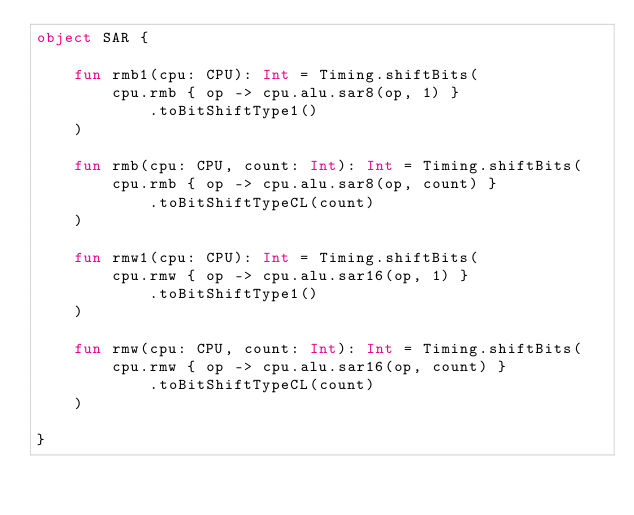Convert code to text. <code><loc_0><loc_0><loc_500><loc_500><_Kotlin_>object SAR {

    fun rmb1(cpu: CPU): Int = Timing.shiftBits(
        cpu.rmb { op -> cpu.alu.sar8(op, 1) }
            .toBitShiftType1()
    )

    fun rmb(cpu: CPU, count: Int): Int = Timing.shiftBits(
        cpu.rmb { op -> cpu.alu.sar8(op, count) }
            .toBitShiftTypeCL(count)
    )

    fun rmw1(cpu: CPU): Int = Timing.shiftBits(
        cpu.rmw { op -> cpu.alu.sar16(op, 1) }
            .toBitShiftType1()
    )

    fun rmw(cpu: CPU, count: Int): Int = Timing.shiftBits(
        cpu.rmw { op -> cpu.alu.sar16(op, count) }
            .toBitShiftTypeCL(count)
    )

}
</code> 